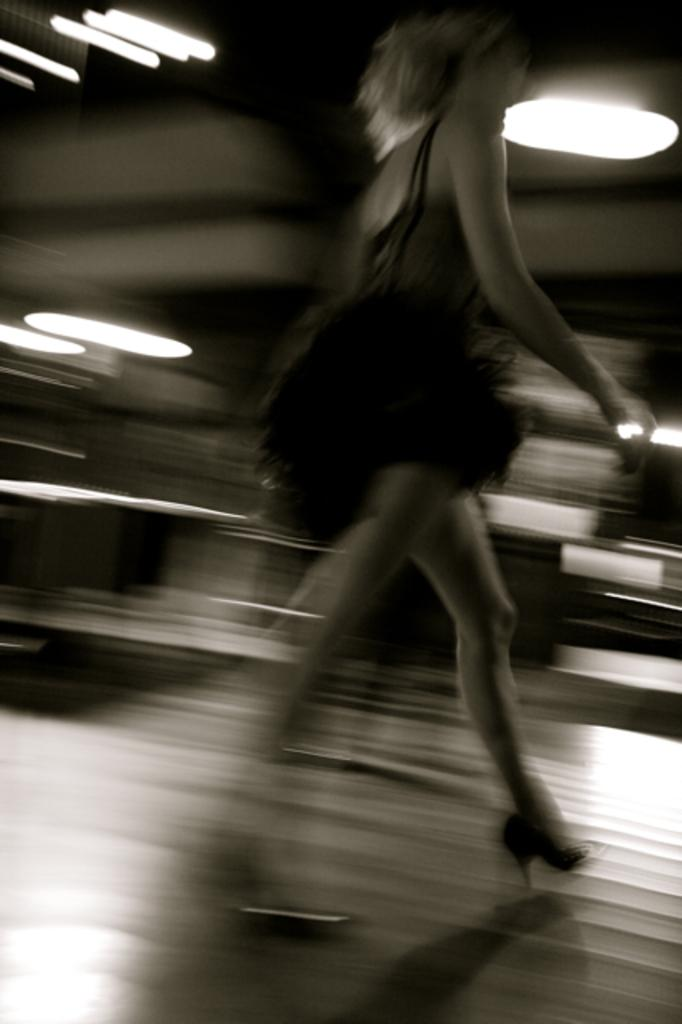Who is the main subject in the image? There is a woman in the image. Where is the woman located in the image? The woman is in the middle of the image. What is the woman wearing? The woman is wearing a dress. What is the woman doing in the image? The woman is walking. What can be seen in the background of the image? There are lights visible in the background of the image. What type of worm can be seen crawling on the woman's dress in the image? There is no worm present on the woman's dress in the image. Is there a cactus visible in the image? There is no cactus present in the image. 